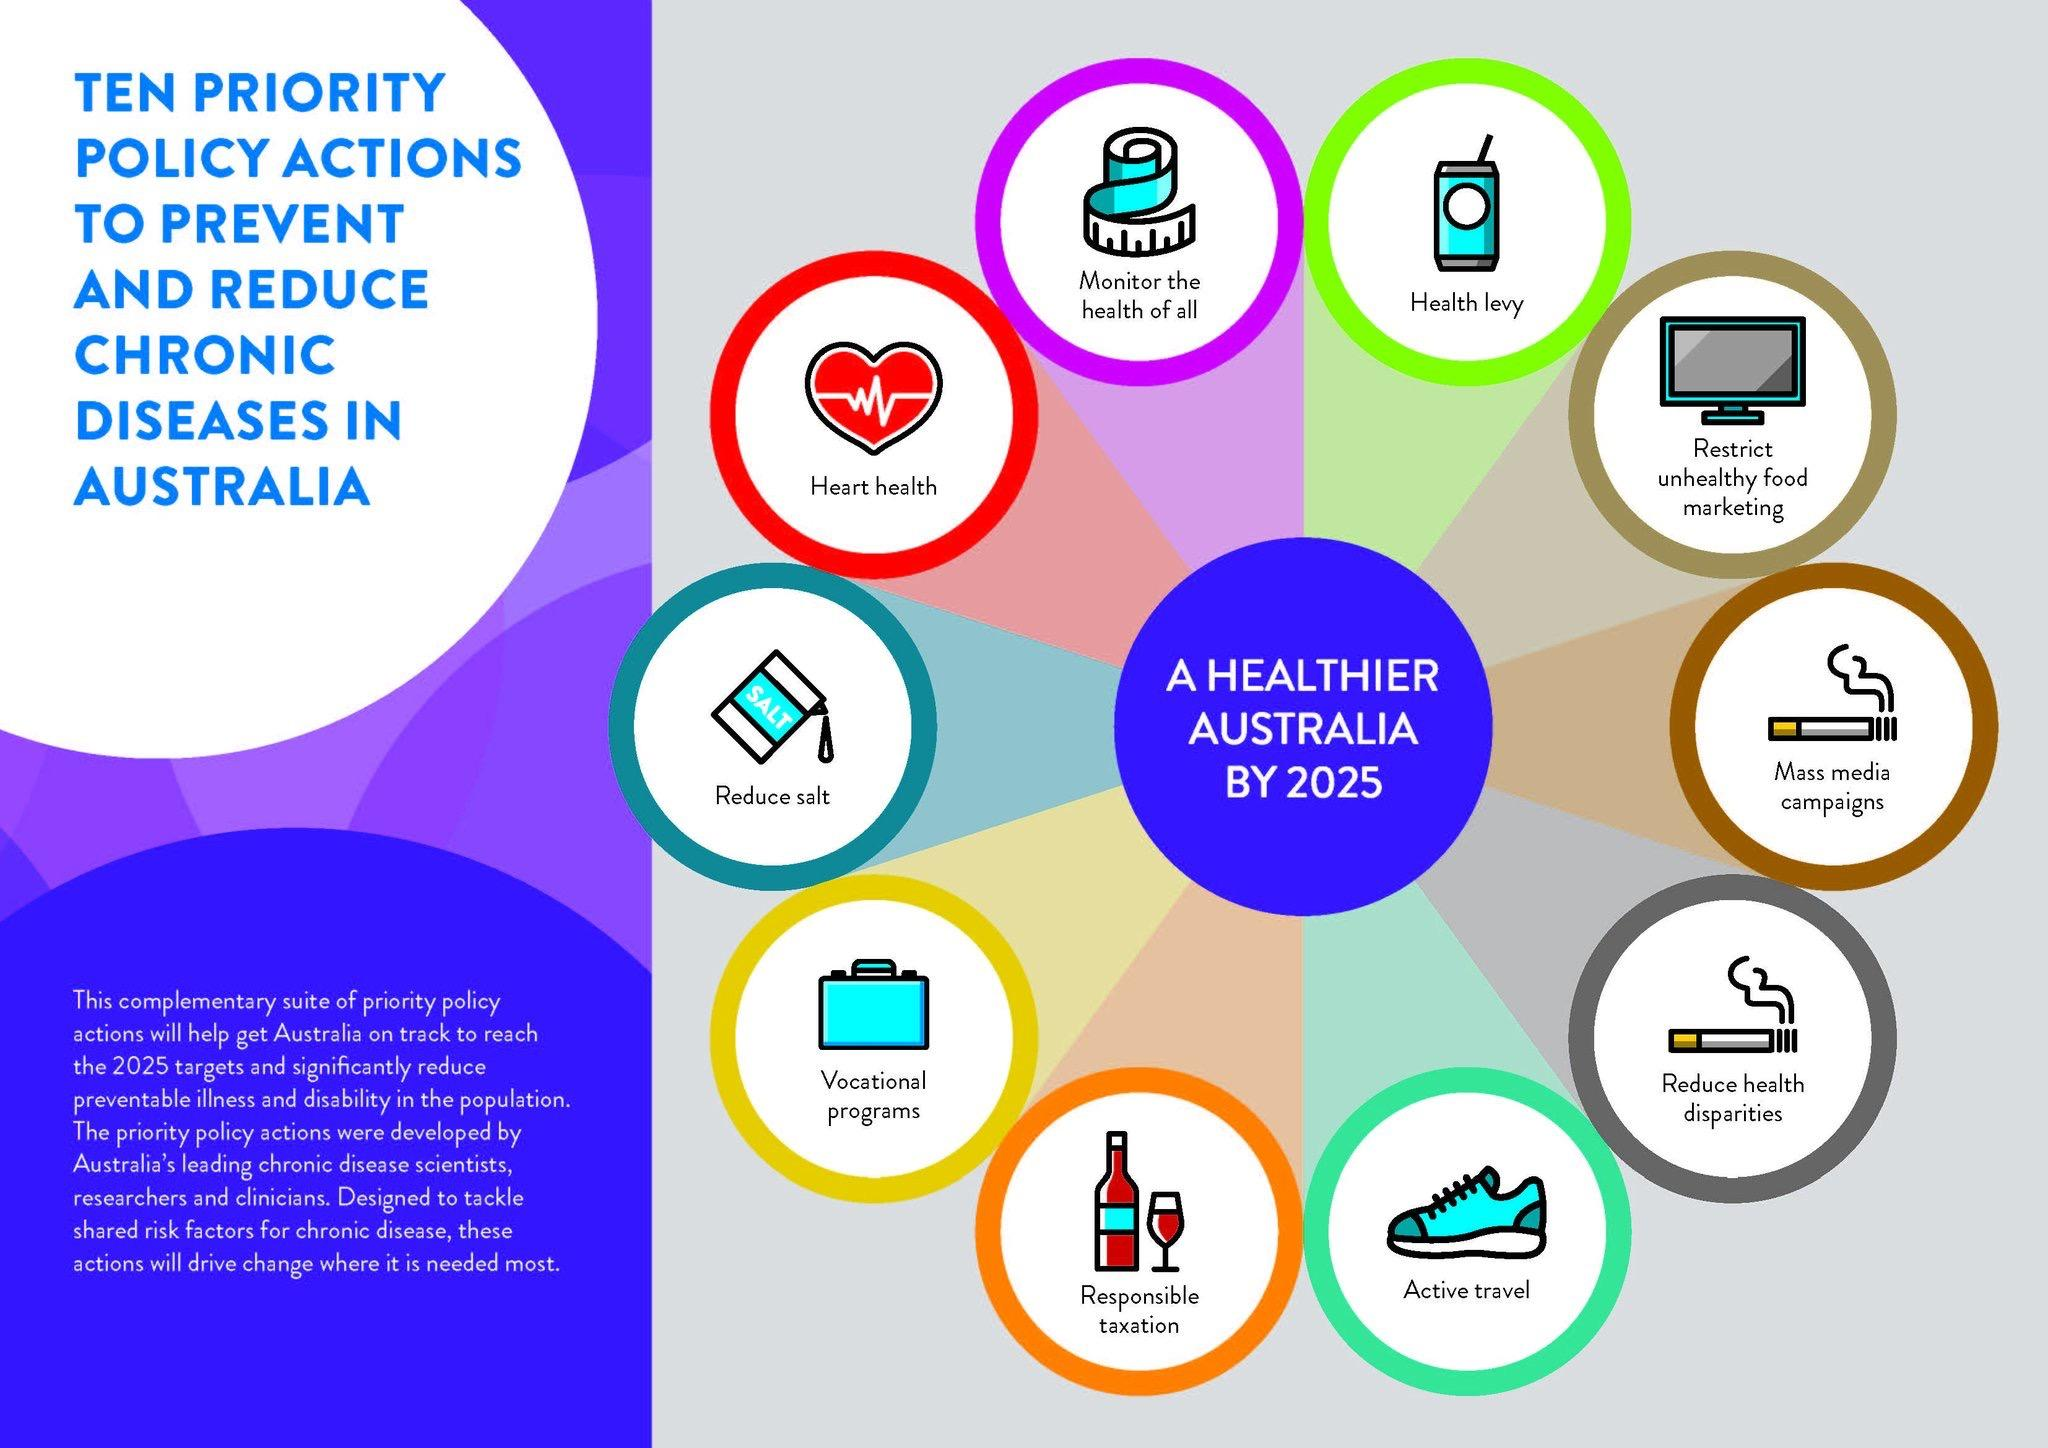Indicate a few pertinent items in this graphic. To reduce smoking, a combination of mass media campaigns and vocational programs should be undertaken. The color of the policy action for heart health is red. Our policy actions, which include mass media campaigns and measures to reduce health disparities, have an image of a cigarette. 